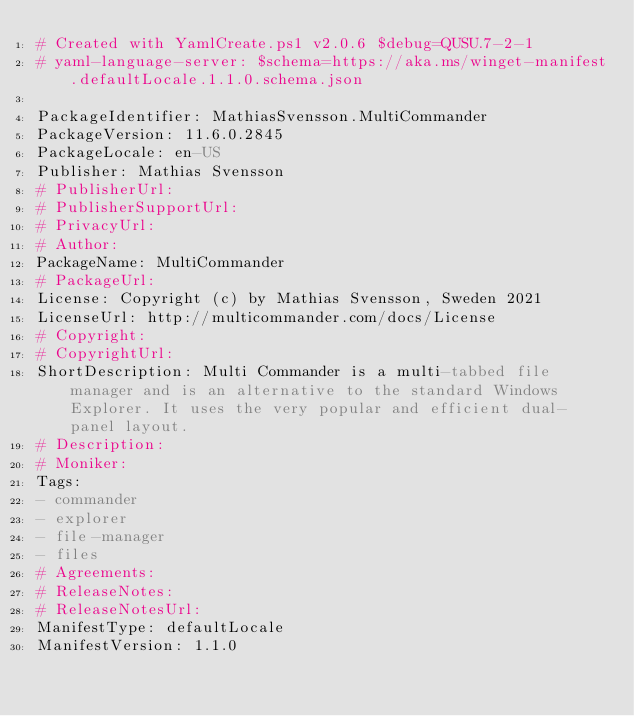Convert code to text. <code><loc_0><loc_0><loc_500><loc_500><_YAML_># Created with YamlCreate.ps1 v2.0.6 $debug=QUSU.7-2-1
# yaml-language-server: $schema=https://aka.ms/winget-manifest.defaultLocale.1.1.0.schema.json

PackageIdentifier: MathiasSvensson.MultiCommander
PackageVersion: 11.6.0.2845
PackageLocale: en-US
Publisher: Mathias Svensson
# PublisherUrl: 
# PublisherSupportUrl: 
# PrivacyUrl: 
# Author: 
PackageName: MultiCommander
# PackageUrl: 
License: Copyright (c) by Mathias Svensson, Sweden 2021
LicenseUrl: http://multicommander.com/docs/License
# Copyright: 
# CopyrightUrl: 
ShortDescription: Multi Commander is a multi-tabbed file manager and is an alternative to the standard Windows Explorer. It uses the very popular and efficient dual-panel layout.
# Description: 
# Moniker: 
Tags:
- commander
- explorer
- file-manager
- files
# Agreements: 
# ReleaseNotes: 
# ReleaseNotesUrl: 
ManifestType: defaultLocale
ManifestVersion: 1.1.0
</code> 